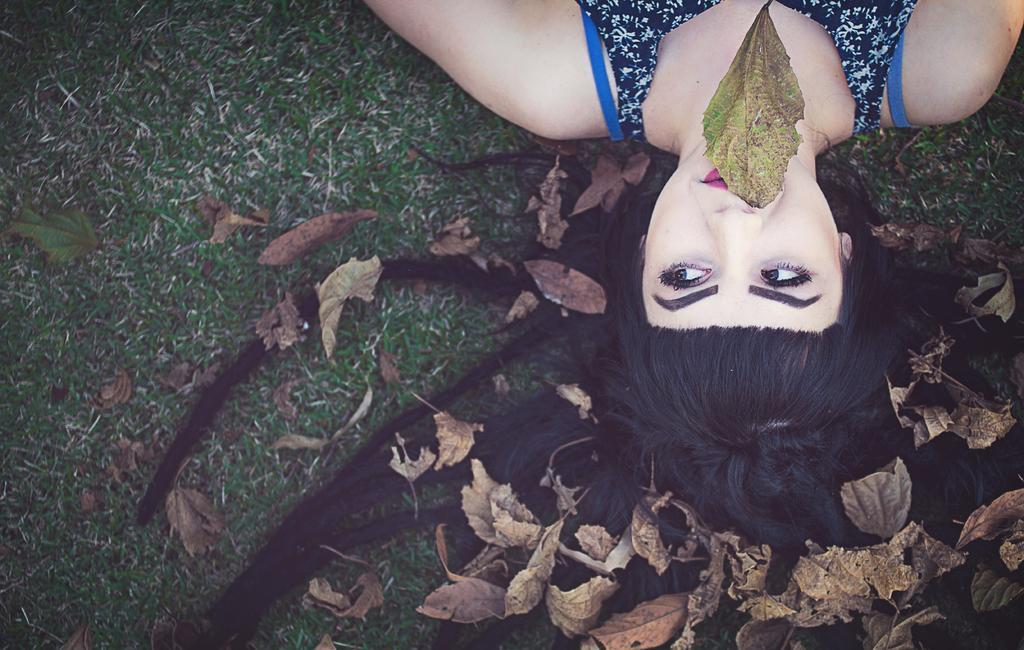How would you summarize this image in a sentence or two? In this image in front there are dry leaves. There is a person laying on the grass and she is holding the dried leaf in her mouth. 